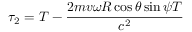<formula> <loc_0><loc_0><loc_500><loc_500>\tau _ { 2 } = T - \frac { 2 m v \omega R \cos { \theta } \sin { \psi } T } { c ^ { 2 } }</formula> 